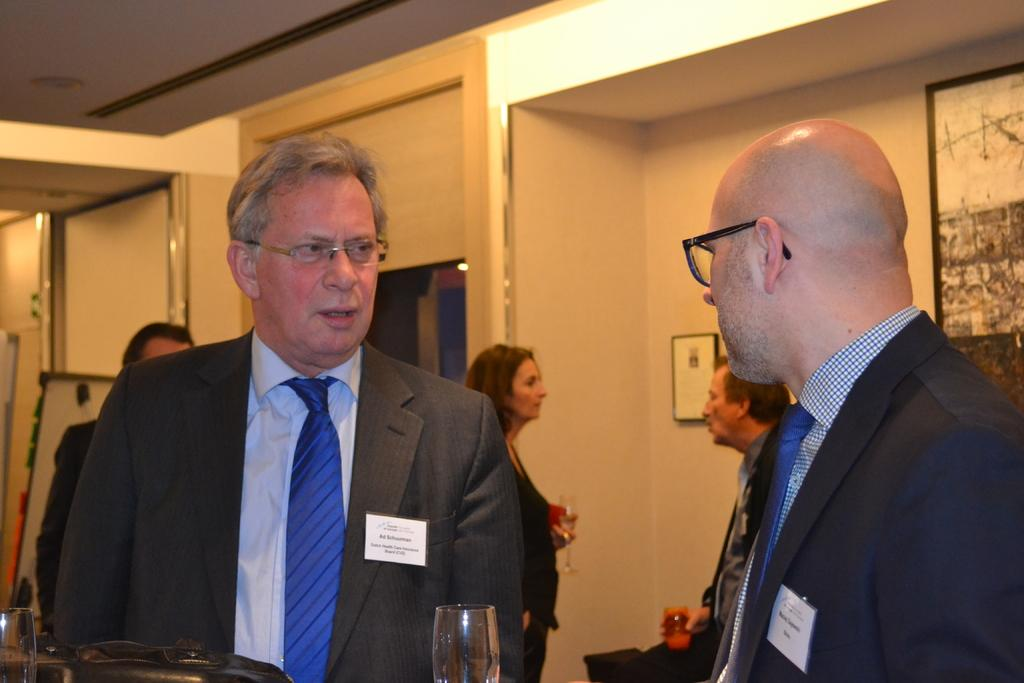What is the main subject of the image? The main subject of the image is a group of people. Where are the people located in the image? The people are standing in a hall. What are some of the people holding in the image? Some of the people are holding glasses. What can be seen in the background of the image? There is a wall with photo frames in the background. How many girls are standing on one foot in the image? There is no information about girls or anyone standing on one foot in the image. 